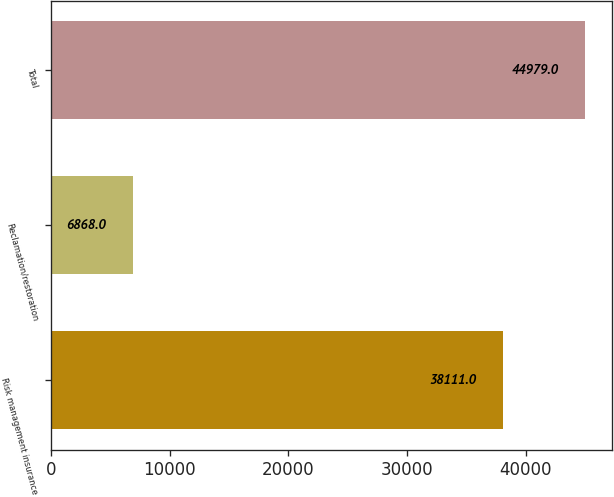<chart> <loc_0><loc_0><loc_500><loc_500><bar_chart><fcel>Risk management insurance<fcel>Reclamation/restoration<fcel>Total<nl><fcel>38111<fcel>6868<fcel>44979<nl></chart> 